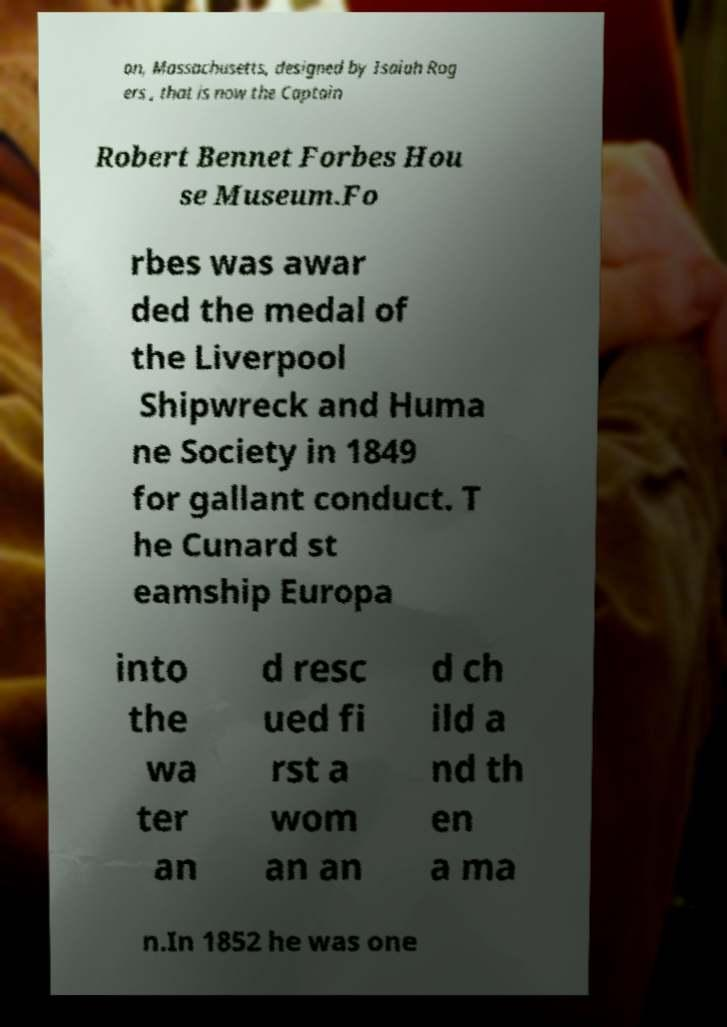Please read and relay the text visible in this image. What does it say? on, Massachusetts, designed by Isaiah Rog ers , that is now the Captain Robert Bennet Forbes Hou se Museum.Fo rbes was awar ded the medal of the Liverpool Shipwreck and Huma ne Society in 1849 for gallant conduct. T he Cunard st eamship Europa into the wa ter an d resc ued fi rst a wom an an d ch ild a nd th en a ma n.In 1852 he was one 